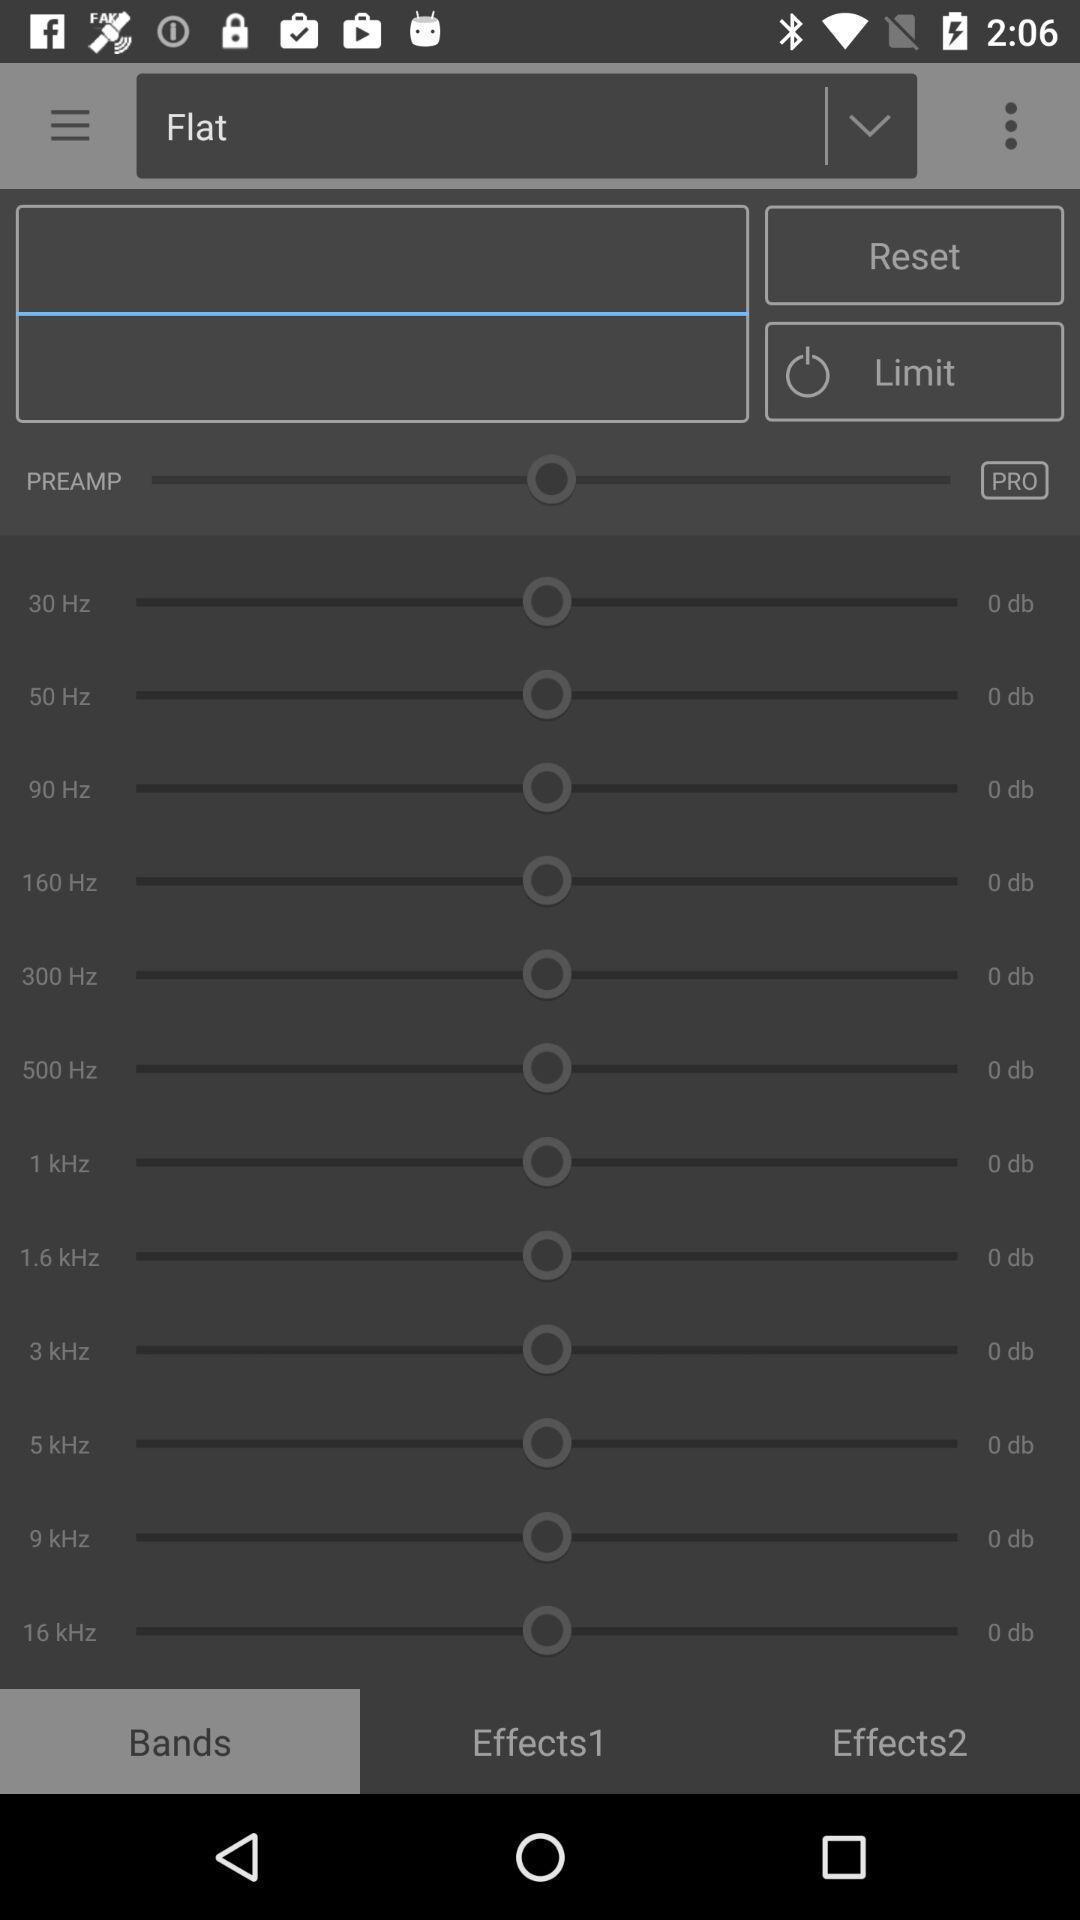What can you discern from this picture? Screen displaying page. 